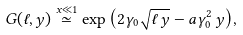<formula> <loc_0><loc_0><loc_500><loc_500>G ( \ell , y ) \stackrel { x \ll 1 } { \simeq } \exp { \left ( 2 \gamma _ { 0 } \sqrt { \ell \, y } - a \gamma _ { 0 } ^ { 2 } \, y \right ) } ,</formula> 